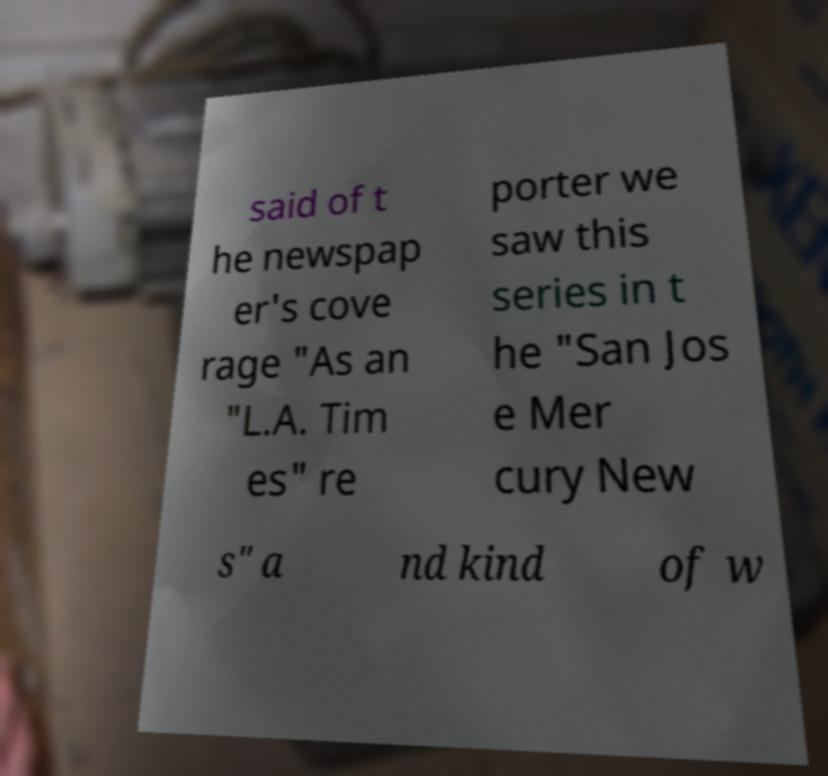What messages or text are displayed in this image? I need them in a readable, typed format. said of t he newspap er's cove rage "As an "L.A. Tim es" re porter we saw this series in t he "San Jos e Mer cury New s" a nd kind of w 